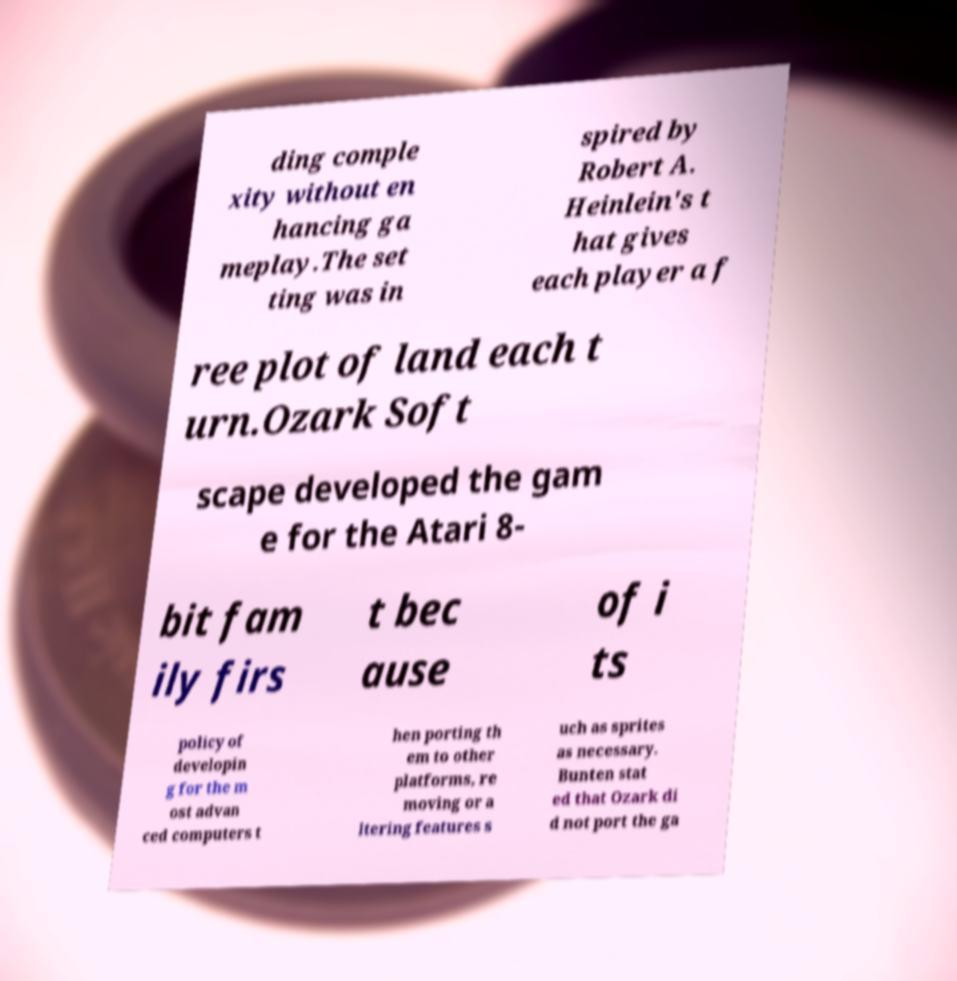Can you read and provide the text displayed in the image?This photo seems to have some interesting text. Can you extract and type it out for me? ding comple xity without en hancing ga meplay.The set ting was in spired by Robert A. Heinlein's t hat gives each player a f ree plot of land each t urn.Ozark Soft scape developed the gam e for the Atari 8- bit fam ily firs t bec ause of i ts policy of developin g for the m ost advan ced computers t hen porting th em to other platforms, re moving or a ltering features s uch as sprites as necessary. Bunten stat ed that Ozark di d not port the ga 